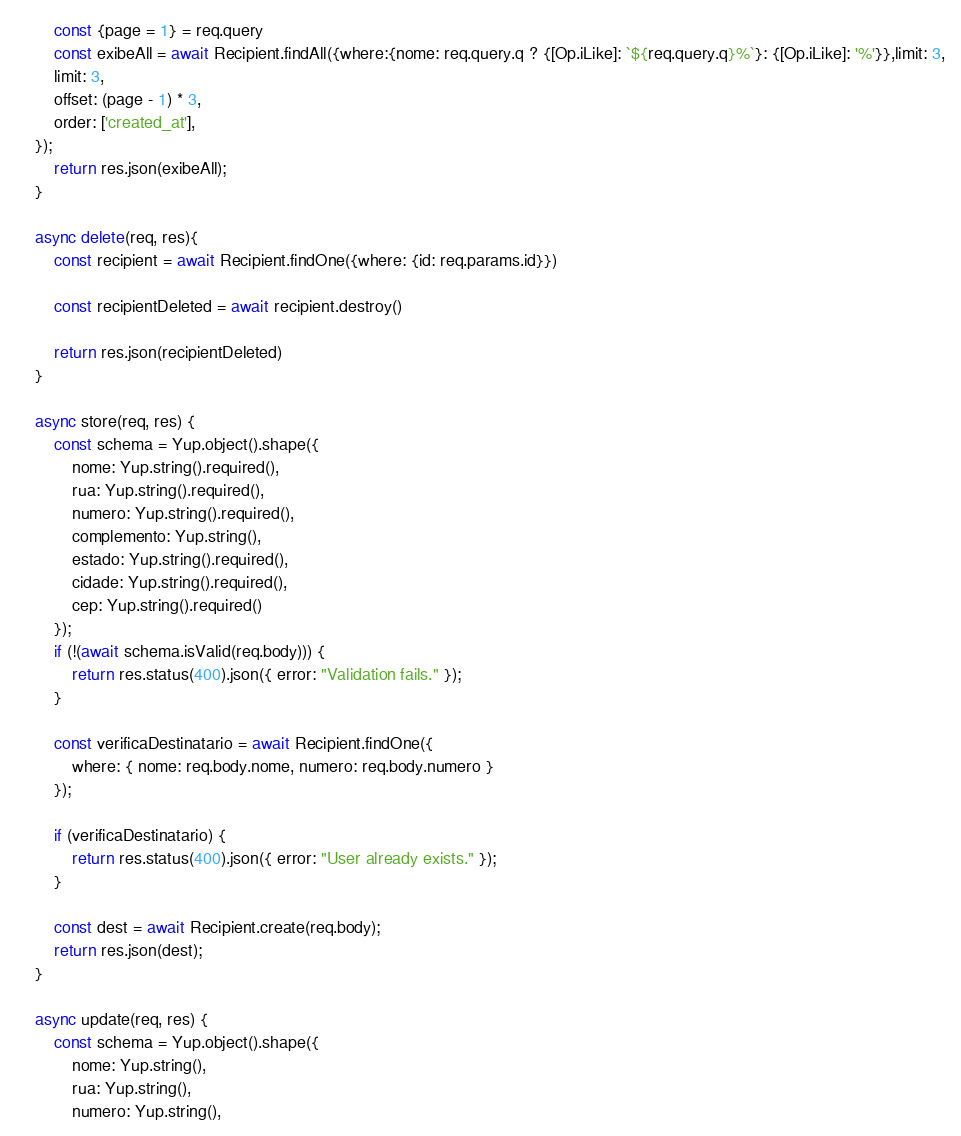<code> <loc_0><loc_0><loc_500><loc_500><_JavaScript_>        const {page = 1} = req.query
        const exibeAll = await Recipient.findAll({where:{nome: req.query.q ? {[Op.iLike]: `${req.query.q}%`}: {[Op.iLike]: '%'}},limit: 3,
        limit: 3,
        offset: (page - 1) * 3,
        order: ['created_at'],
    });
        return res.json(exibeAll);
    }

    async delete(req, res){
        const recipient = await Recipient.findOne({where: {id: req.params.id}})

        const recipientDeleted = await recipient.destroy()

        return res.json(recipientDeleted)
    }

    async store(req, res) {
        const schema = Yup.object().shape({
            nome: Yup.string().required(),
            rua: Yup.string().required(),
            numero: Yup.string().required(),
            complemento: Yup.string(),
            estado: Yup.string().required(),
            cidade: Yup.string().required(),
            cep: Yup.string().required()
        });
        if (!(await schema.isValid(req.body))) {
            return res.status(400).json({ error: "Validation fails." });
        }

        const verificaDestinatario = await Recipient.findOne({
            where: { nome: req.body.nome, numero: req.body.numero }
        });

        if (verificaDestinatario) {
            return res.status(400).json({ error: "User already exists." });
        }

        const dest = await Recipient.create(req.body);
        return res.json(dest);
    }

    async update(req, res) {
        const schema = Yup.object().shape({
            nome: Yup.string(),
            rua: Yup.string(),
            numero: Yup.string(),</code> 